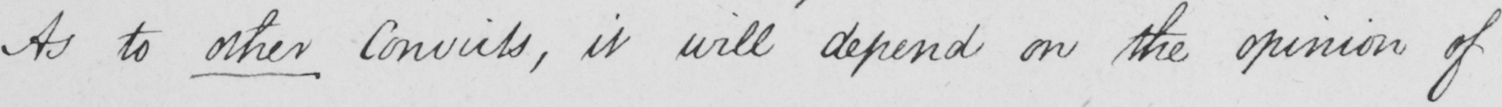Please transcribe the handwritten text in this image. As to other Convicts , it will depend on the opinion of 